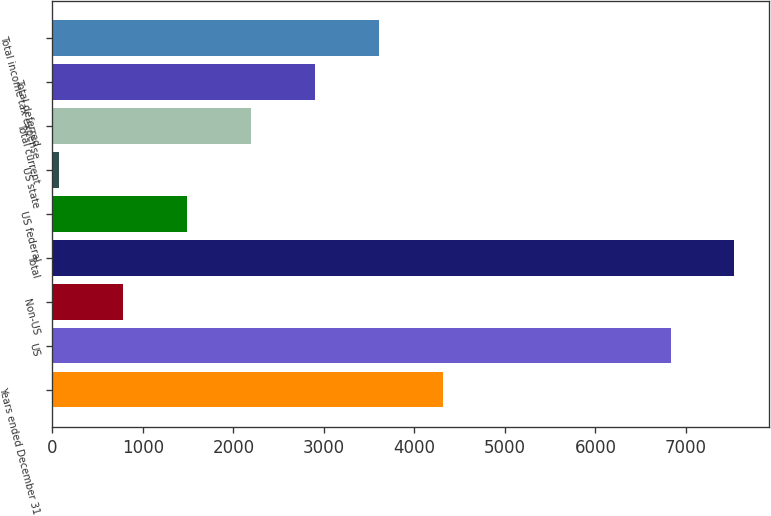Convert chart to OTSL. <chart><loc_0><loc_0><loc_500><loc_500><bar_chart><fcel>Years ended December 31<fcel>US<fcel>Non-US<fcel>Total<fcel>US federal<fcel>US state<fcel>Total current<fcel>Total deferred<fcel>Total income tax expense<nl><fcel>4309.8<fcel>6829<fcel>775.8<fcel>7535.8<fcel>1482.6<fcel>69<fcel>2189.4<fcel>2896.2<fcel>3603<nl></chart> 